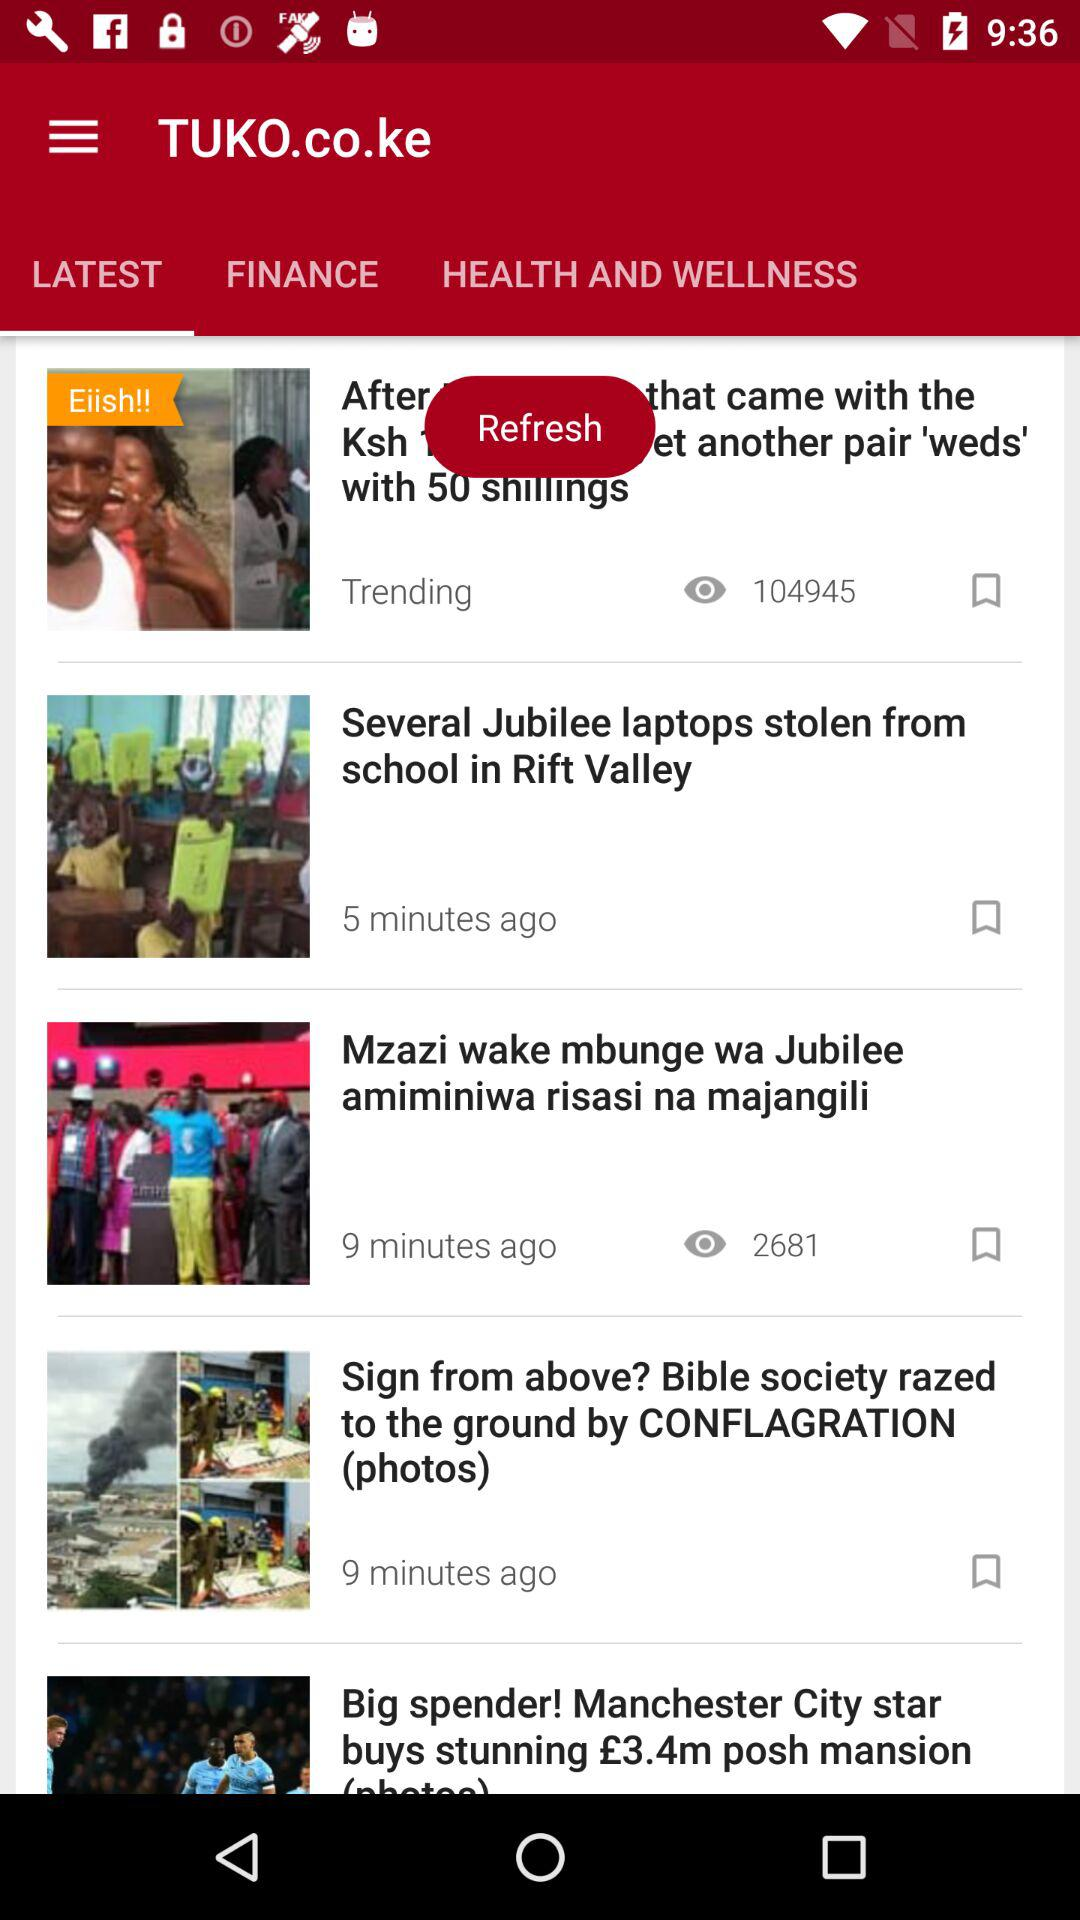Which news was published 9 minutes ago? The news that were published 9 minutes ago are "Mzazi wake mbunge wa Jubilee amiminiwa risasi na majangili" and "Sign from above? Bible society razed to the ground by CONFLAGRATION (photos)". 